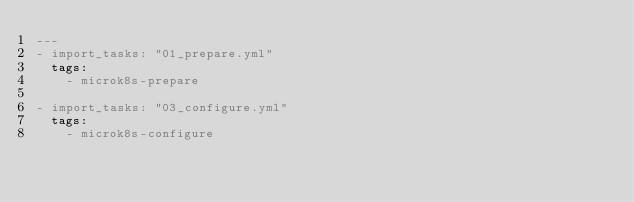Convert code to text. <code><loc_0><loc_0><loc_500><loc_500><_YAML_>---
- import_tasks: "01_prepare.yml"
  tags:
    - microk8s-prepare

- import_tasks: "03_configure.yml"
  tags:
    - microk8s-configure
</code> 